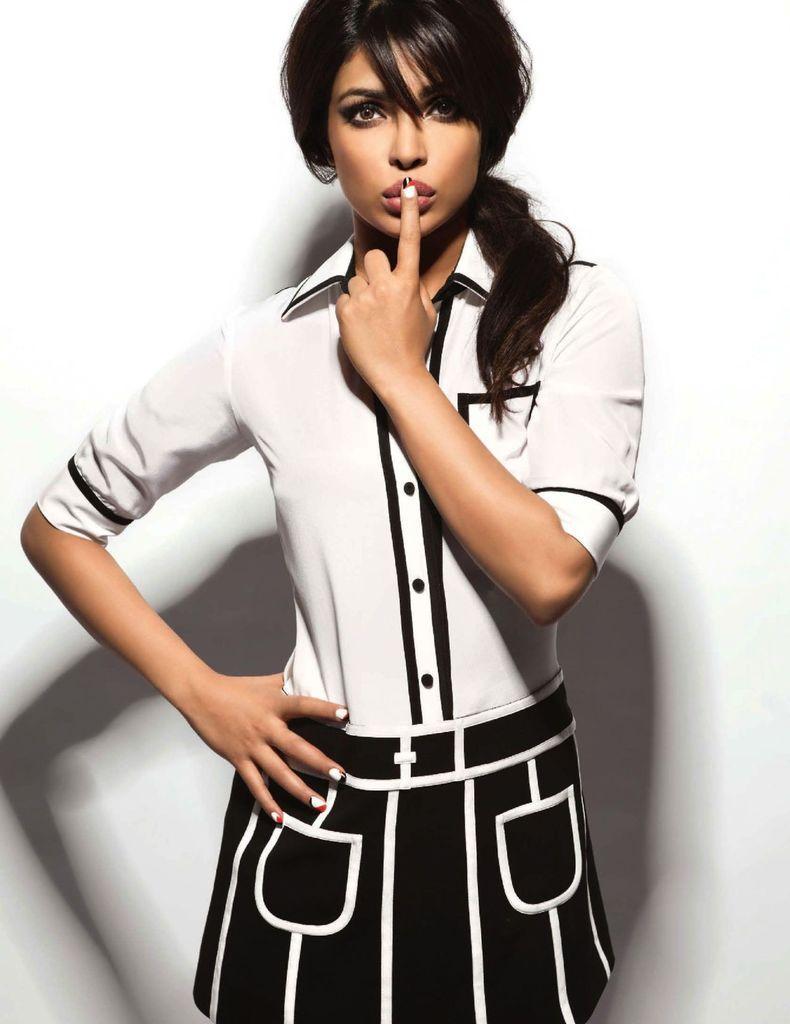Can you describe this image briefly? In the image there is a woman in white shirt and black frock standing in front of the white wall. 